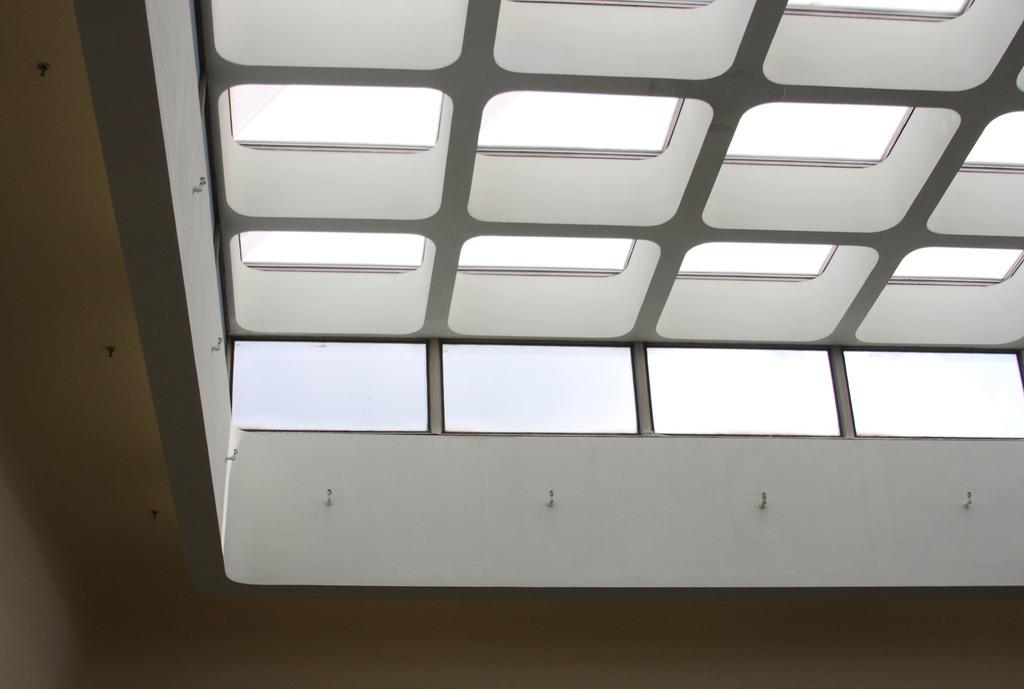What is present on the upper part of the room in the image? There is a ceiling in the image. What is unique about the design of the ceiling? The ceiling is designed to resemble a window. Who is the creator of the tent in the image? There is no tent present in the image; it features a ceiling designed to resemble a window. 